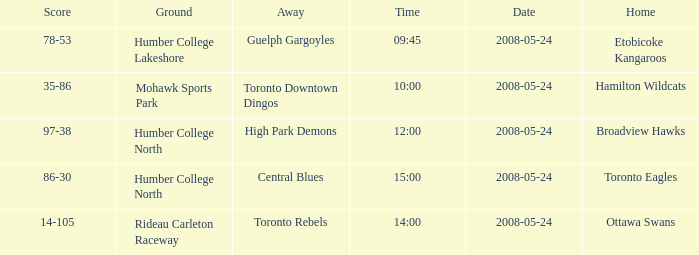On what day was the game that ended in a score of 97-38? 2008-05-24. 